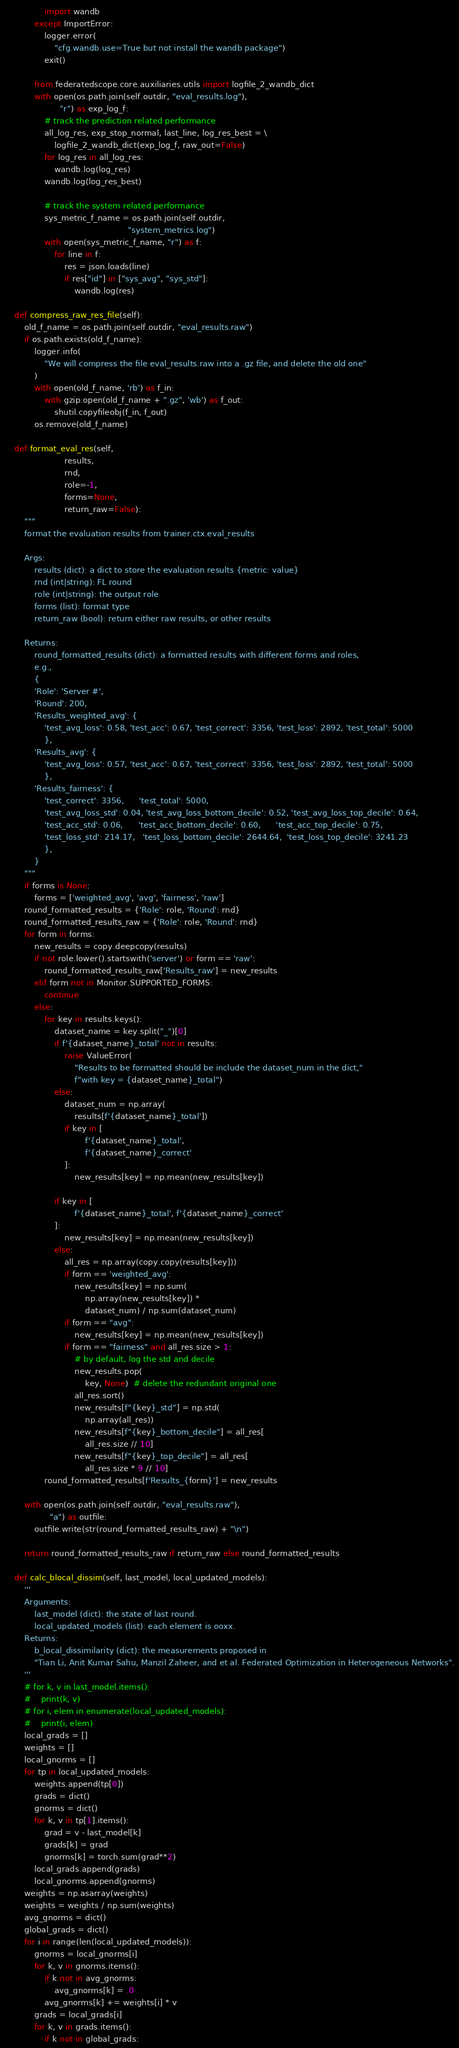Convert code to text. <code><loc_0><loc_0><loc_500><loc_500><_Python_>                import wandb
            except ImportError:
                logger.error(
                    "cfg.wandb.use=True but not install the wandb package")
                exit()

            from federatedscope.core.auxiliaries.utils import logfile_2_wandb_dict
            with open(os.path.join(self.outdir, "eval_results.log"),
                      "r") as exp_log_f:
                # track the prediction related performance
                all_log_res, exp_stop_normal, last_line, log_res_best = \
                    logfile_2_wandb_dict(exp_log_f, raw_out=False)
                for log_res in all_log_res:
                    wandb.log(log_res)
                wandb.log(log_res_best)

                # track the system related performance
                sys_metric_f_name = os.path.join(self.outdir,
                                                 "system_metrics.log")
                with open(sys_metric_f_name, "r") as f:
                    for line in f:
                        res = json.loads(line)
                        if res["id"] in ["sys_avg", "sys_std"]:
                            wandb.log(res)

    def compress_raw_res_file(self):
        old_f_name = os.path.join(self.outdir, "eval_results.raw")
        if os.path.exists(old_f_name):
            logger.info(
                "We will compress the file eval_results.raw into a .gz file, and delete the old one"
            )
            with open(old_f_name, 'rb') as f_in:
                with gzip.open(old_f_name + ".gz", 'wb') as f_out:
                    shutil.copyfileobj(f_in, f_out)
            os.remove(old_f_name)

    def format_eval_res(self,
                        results,
                        rnd,
                        role=-1,
                        forms=None,
                        return_raw=False):
        """
        format the evaluation results from trainer.ctx.eval_results

        Args:
            results (dict): a dict to store the evaluation results {metric: value}
            rnd (int|string): FL round
            role (int|string): the output role
            forms (list): format type
            return_raw (bool): return either raw results, or other results

        Returns:
            round_formatted_results (dict): a formatted results with different forms and roles,
            e.g.,
            {
            'Role': 'Server #',
            'Round': 200,
            'Results_weighted_avg': {
                'test_avg_loss': 0.58, 'test_acc': 0.67, 'test_correct': 3356, 'test_loss': 2892, 'test_total': 5000
                },
            'Results_avg': {
                'test_avg_loss': 0.57, 'test_acc': 0.67, 'test_correct': 3356, 'test_loss': 2892, 'test_total': 5000
                },
            'Results_fairness': {
                'test_correct': 3356,      'test_total': 5000,
                'test_avg_loss_std': 0.04, 'test_avg_loss_bottom_decile': 0.52, 'test_avg_loss_top_decile': 0.64,
                'test_acc_std': 0.06,      'test_acc_bottom_decile': 0.60,      'test_acc_top_decile': 0.75,
                'test_loss_std': 214.17,   'test_loss_bottom_decile': 2644.64,  'test_loss_top_decile': 3241.23
                },
            }
        """
        if forms is None:
            forms = ['weighted_avg', 'avg', 'fairness', 'raw']
        round_formatted_results = {'Role': role, 'Round': rnd}
        round_formatted_results_raw = {'Role': role, 'Round': rnd}
        for form in forms:
            new_results = copy.deepcopy(results)
            if not role.lower().startswith('server') or form == 'raw':
                round_formatted_results_raw['Results_raw'] = new_results
            elif form not in Monitor.SUPPORTED_FORMS:
                continue
            else:
                for key in results.keys():
                    dataset_name = key.split("_")[0]
                    if f'{dataset_name}_total' not in results:
                        raise ValueError(
                            "Results to be formatted should be include the dataset_num in the dict,"
                            f"with key = {dataset_name}_total")
                    else:
                        dataset_num = np.array(
                            results[f'{dataset_name}_total'])
                        if key in [
                                f'{dataset_name}_total',
                                f'{dataset_name}_correct'
                        ]:
                            new_results[key] = np.mean(new_results[key])

                    if key in [
                            f'{dataset_name}_total', f'{dataset_name}_correct'
                    ]:
                        new_results[key] = np.mean(new_results[key])
                    else:
                        all_res = np.array(copy.copy(results[key]))
                        if form == 'weighted_avg':
                            new_results[key] = np.sum(
                                np.array(new_results[key]) *
                                dataset_num) / np.sum(dataset_num)
                        if form == "avg":
                            new_results[key] = np.mean(new_results[key])
                        if form == "fairness" and all_res.size > 1:
                            # by default, log the std and decile
                            new_results.pop(
                                key, None)  # delete the redundant original one
                            all_res.sort()
                            new_results[f"{key}_std"] = np.std(
                                np.array(all_res))
                            new_results[f"{key}_bottom_decile"] = all_res[
                                all_res.size // 10]
                            new_results[f"{key}_top_decile"] = all_res[
                                all_res.size * 9 // 10]
                round_formatted_results[f'Results_{form}'] = new_results

        with open(os.path.join(self.outdir, "eval_results.raw"),
                  "a") as outfile:
            outfile.write(str(round_formatted_results_raw) + "\n")

        return round_formatted_results_raw if return_raw else round_formatted_results

    def calc_blocal_dissim(self, last_model, local_updated_models):
        '''
        Arguments:
            last_model (dict): the state of last round.
            local_updated_models (list): each element is ooxx.
        Returns:
            b_local_dissimilarity (dict): the measurements proposed in
            "Tian Li, Anit Kumar Sahu, Manzil Zaheer, and et al. Federated Optimization in Heterogeneous Networks".
        '''
        # for k, v in last_model.items():
        #    print(k, v)
        # for i, elem in enumerate(local_updated_models):
        #    print(i, elem)
        local_grads = []
        weights = []
        local_gnorms = []
        for tp in local_updated_models:
            weights.append(tp[0])
            grads = dict()
            gnorms = dict()
            for k, v in tp[1].items():
                grad = v - last_model[k]
                grads[k] = grad
                gnorms[k] = torch.sum(grad**2)
            local_grads.append(grads)
            local_gnorms.append(gnorms)
        weights = np.asarray(weights)
        weights = weights / np.sum(weights)
        avg_gnorms = dict()
        global_grads = dict()
        for i in range(len(local_updated_models)):
            gnorms = local_gnorms[i]
            for k, v in gnorms.items():
                if k not in avg_gnorms:
                    avg_gnorms[k] = .0
                avg_gnorms[k] += weights[i] * v
            grads = local_grads[i]
            for k, v in grads.items():
                if k not in global_grads:</code> 